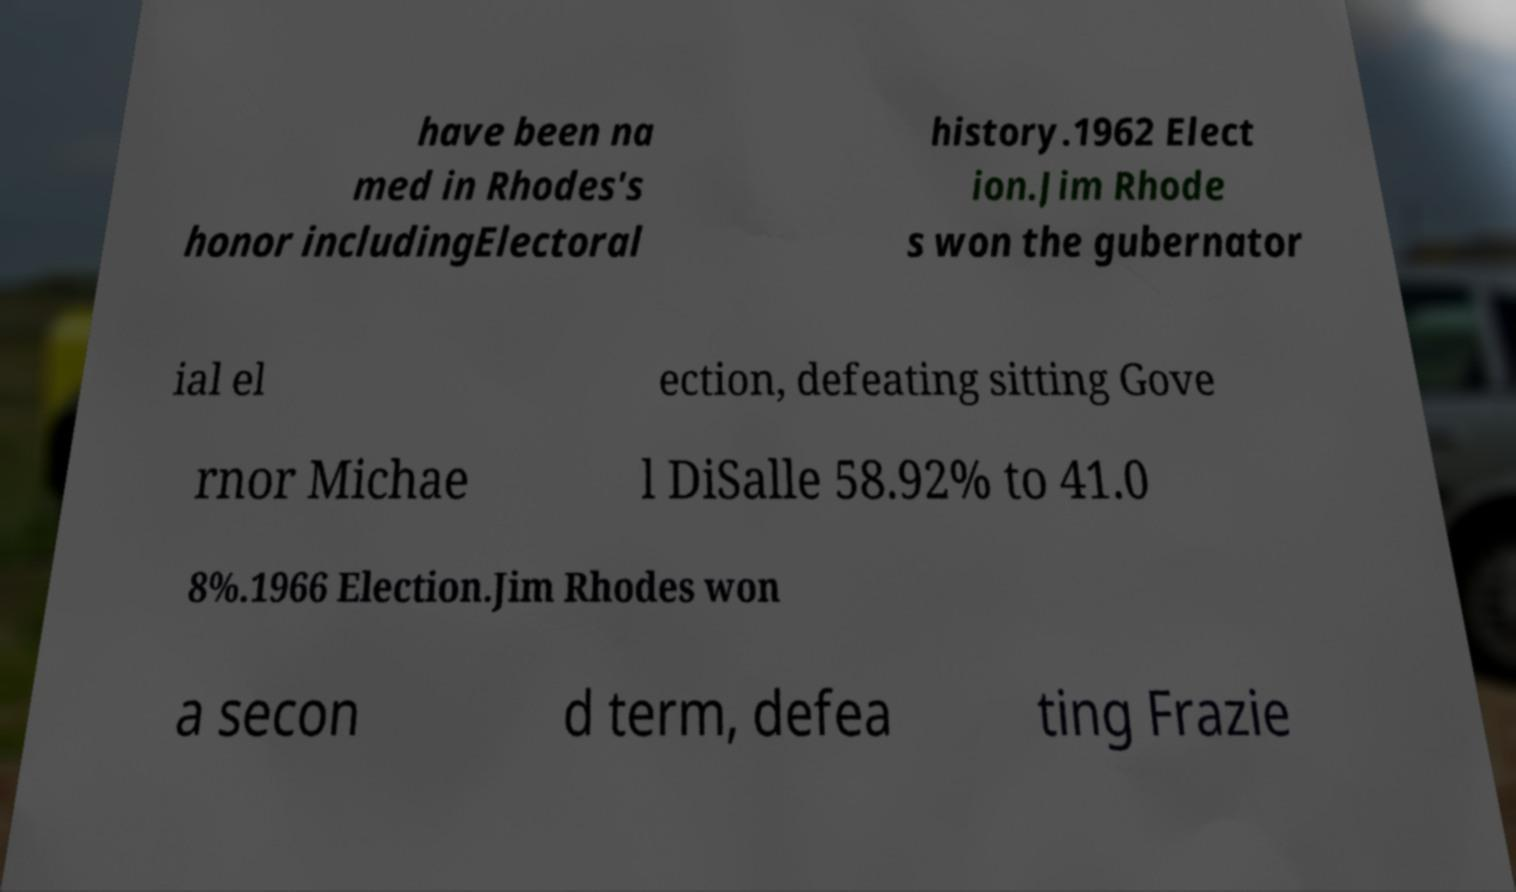Please read and relay the text visible in this image. What does it say? have been na med in Rhodes's honor includingElectoral history.1962 Elect ion.Jim Rhode s won the gubernator ial el ection, defeating sitting Gove rnor Michae l DiSalle 58.92% to 41.0 8%.1966 Election.Jim Rhodes won a secon d term, defea ting Frazie 